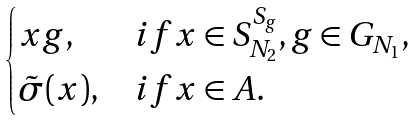<formula> <loc_0><loc_0><loc_500><loc_500>\begin{cases} x g , & i f x \in S ^ { S _ { g } } _ { N _ { 2 } } , g \in G _ { N _ { 1 } } , \\ \tilde { \sigma } ( x ) , & i f x \in A . \end{cases}</formula> 